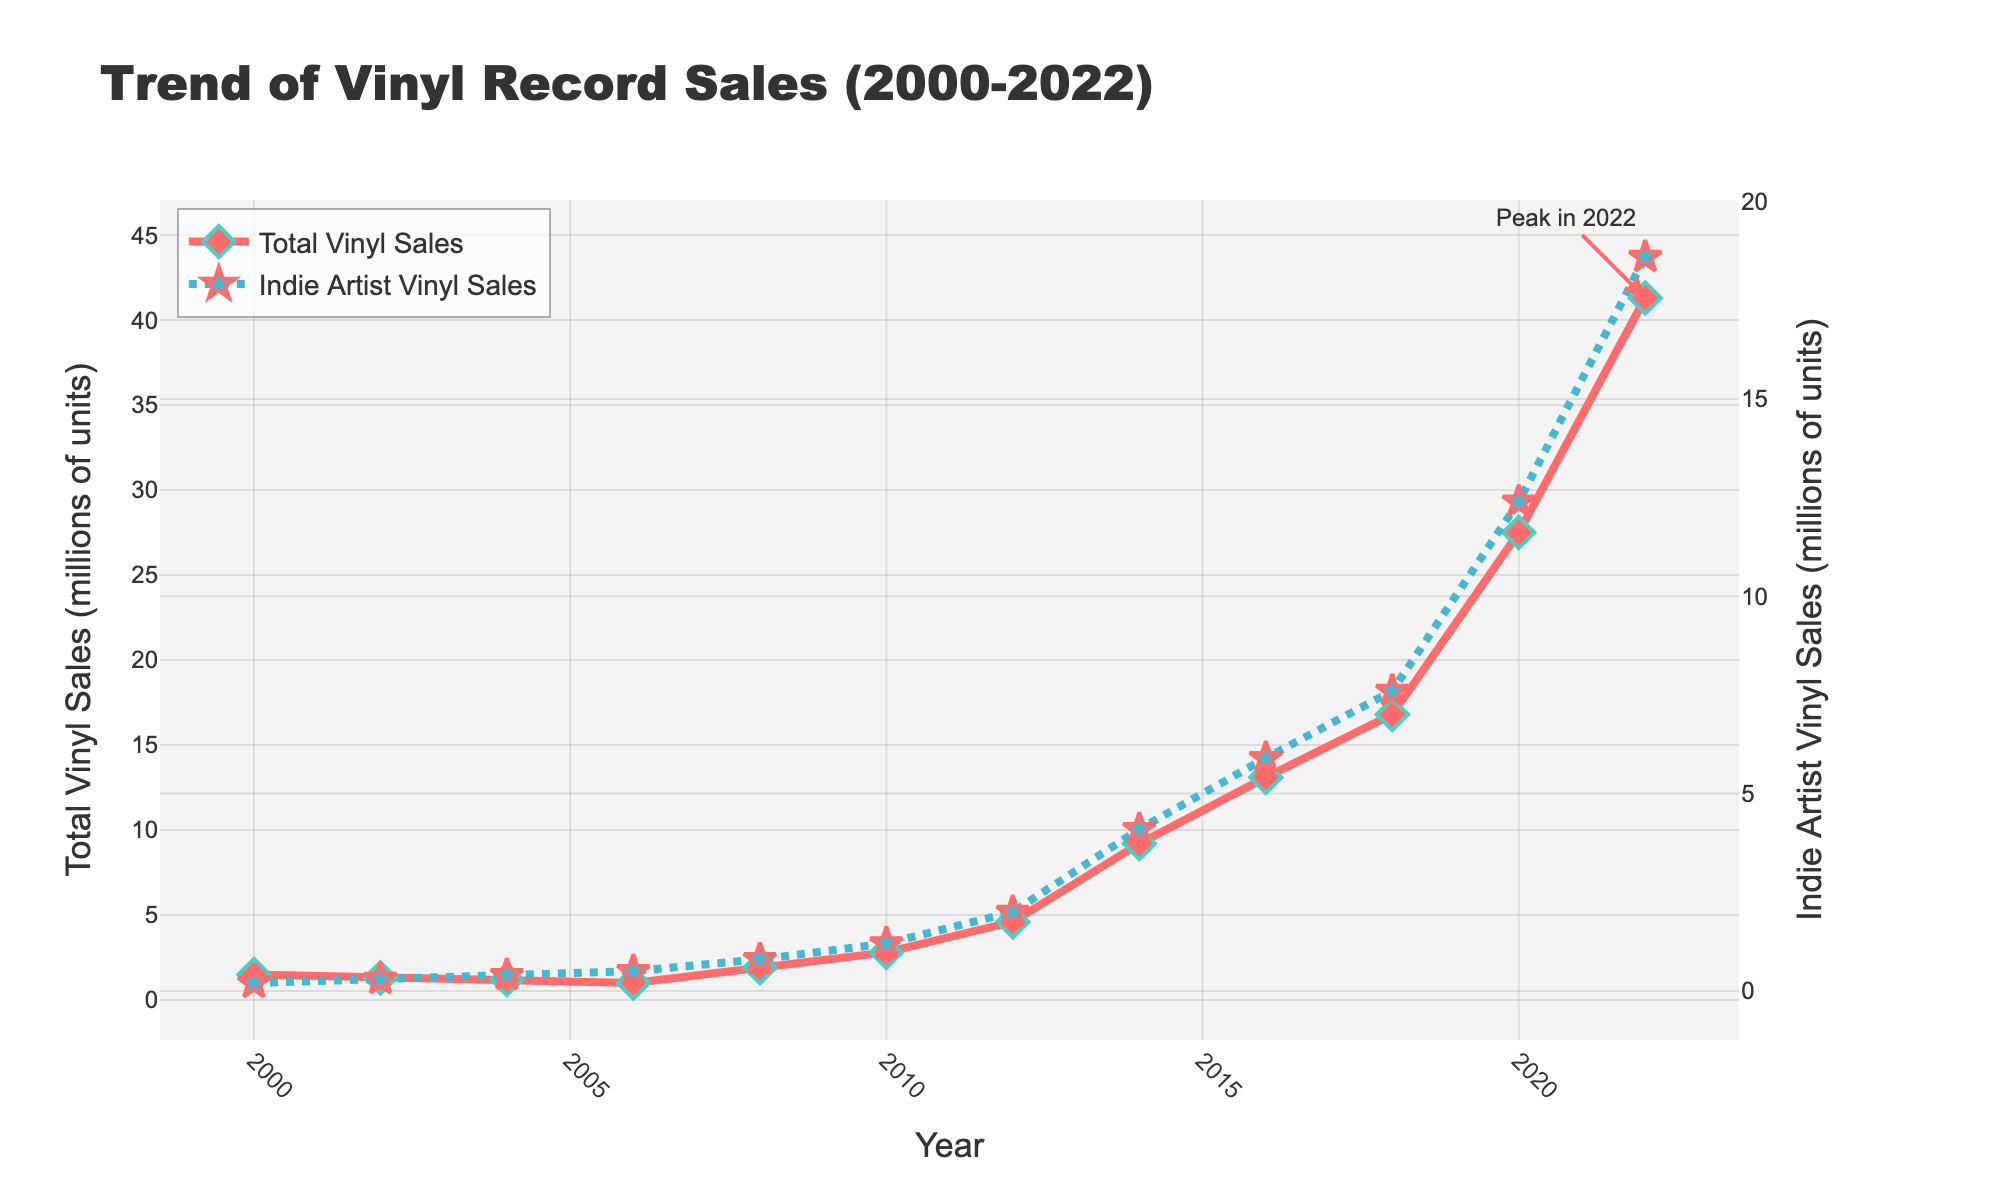which year shows the highest total vinyl sales? The highest vinyl sales are observed in the year 2022, where the Total Vinyl Sales reaches 41.3 million units.
Answer: 2022 How do indie artist vinyl sales in year 2006 compare to 2002? Indie artist vinyl sales in 2006 are higher than in 2002. In 2006, sales are 0.5 million units, compared to 0.3 million units in 2002.
Answer: 0.2 million units higher What's the difference in total vinyl sales between 2018 and 2022? Total vinyl sales in 2018 are 16.8 million units, and in 2022 they are 41.3 million units. The difference is 41.3 - 16.8 = 24.5 million units.
Answer: 24.5 million units Can you identify a year where the total vinyl sales and indie artist vinyl sales grew at similar rates? Between 2006 and 2008, both total vinyl sales and indie artist vinyl sales show a similar increase. Total vinyl sales increase from 1.0 to 1.9 million units (0.9 million units increase), and indie artist sales increase from 0.5 to 0.8 million units (0.3 million units increase).
Answer: 2006 to 2008 What is the trend of indie artist vinyl sales from 2000 to 2022? Indie artist vinyl sales show a general upward trend, starting from 0.2 million units in 2000 and increasing steadily to reach 18.6 million units by 2022.
Answer: upward trend How does the peak in indie artist vinyl sales in 2022 compare to the total vinyl sales that year? In 2022, indie artist vinyl sales are at 18.6 million units while total vinyl sales are 41.3 million units. Indie artist sales are significantly lower than the total sales, but they contribute a substantial portion.
Answer: significantly lower What was the growth in indie artist vinyl sales from 2010 to 2014? Indie artist vinyl sales grew from 1.2 million units in 2010 to 4.1 million units in 2014. The growth is 4.1 - 1.2 = 2.9 million units.
Answer: 2.9 million units Between which years did the total vinyl sales see the most rapid increase? The most rapid increase in total vinyl sales appears between 2018 and 2020, where sales rise from 16.8 million units to 27.5 million units. This is an increase of 10.7 million units.
Answer: 2018 to 2020 In which year did indie artist vinyl sales first surpass 4 million units? Indie artist vinyl sales first surpass 4 million units in 2014, when they reach 4.1 million units.
Answer: 2014 